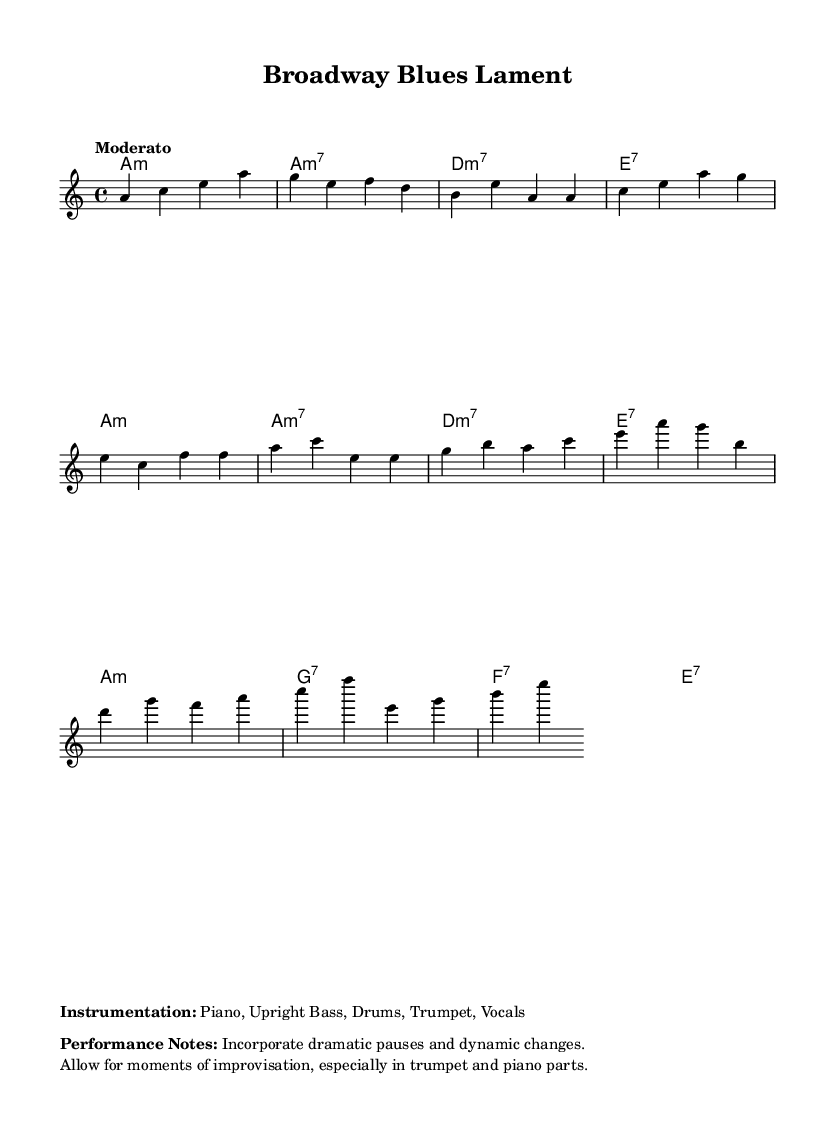What is the key signature of this music? The key signature is A minor, as indicated by the absence of sharps and flats in the staff along with the contextual indication in the music.
Answer: A minor What is the time signature of the piece? The time signature is 4/4, which means there are four beats per measure and the quarter note gets one beat. This is explicitly indicated at the beginning of the sheet music.
Answer: 4/4 What is the tempo marking for the performance? The tempo marking is "Moderato," which suggests a moderate speed for the piece. This is directly stated in the sheet music.
Answer: Moderato How many measures are in the verse section? The verse section contains six measures, as counted from the beginning of the verse notes to the end. By ensuring each line represents a measure, we can tally the total.
Answer: 6 Which instruments are included in the performance? The instrumentation listed includes Piano, Upright Bass, Drums, Trumpet, and Vocals, as described in the markup section of the music.
Answer: Piano, Upright Bass, Drums, Trumpet, Vocals What is a suggested performance note for the piece? One suggested performance note is to "Incorporate dramatic pauses and dynamic changes," which is outlined in the markup section indicating expressive elements in the performance.
Answer: Incorporate dramatic pauses and dynamic changes What chord follows the A minor chord in the intro? The chord that follows the A minor chord is an A minor seventh chord, indicated in the chord changes right after the A minor symbol in the intro.
Answer: A minor seventh 